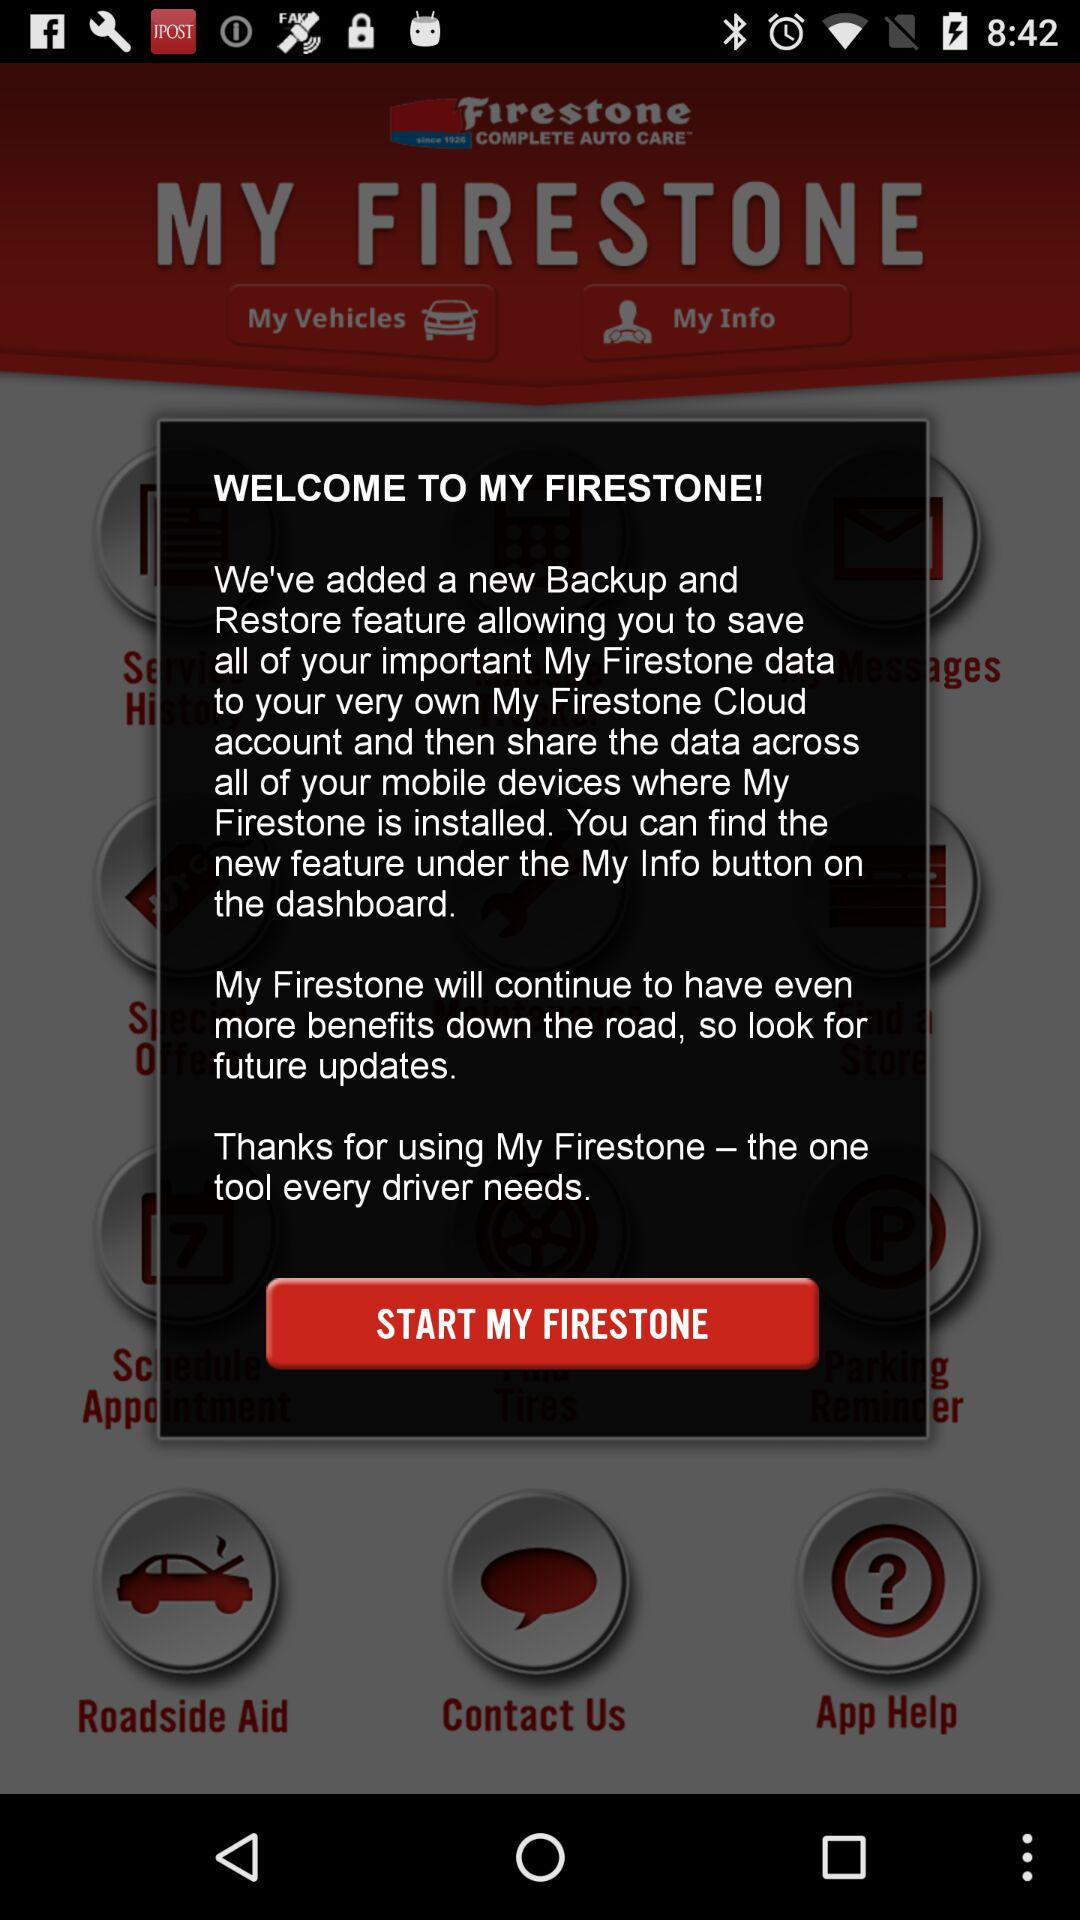Under which button can the new feature be seen? The new feature can be seen under the "My Info" button. 